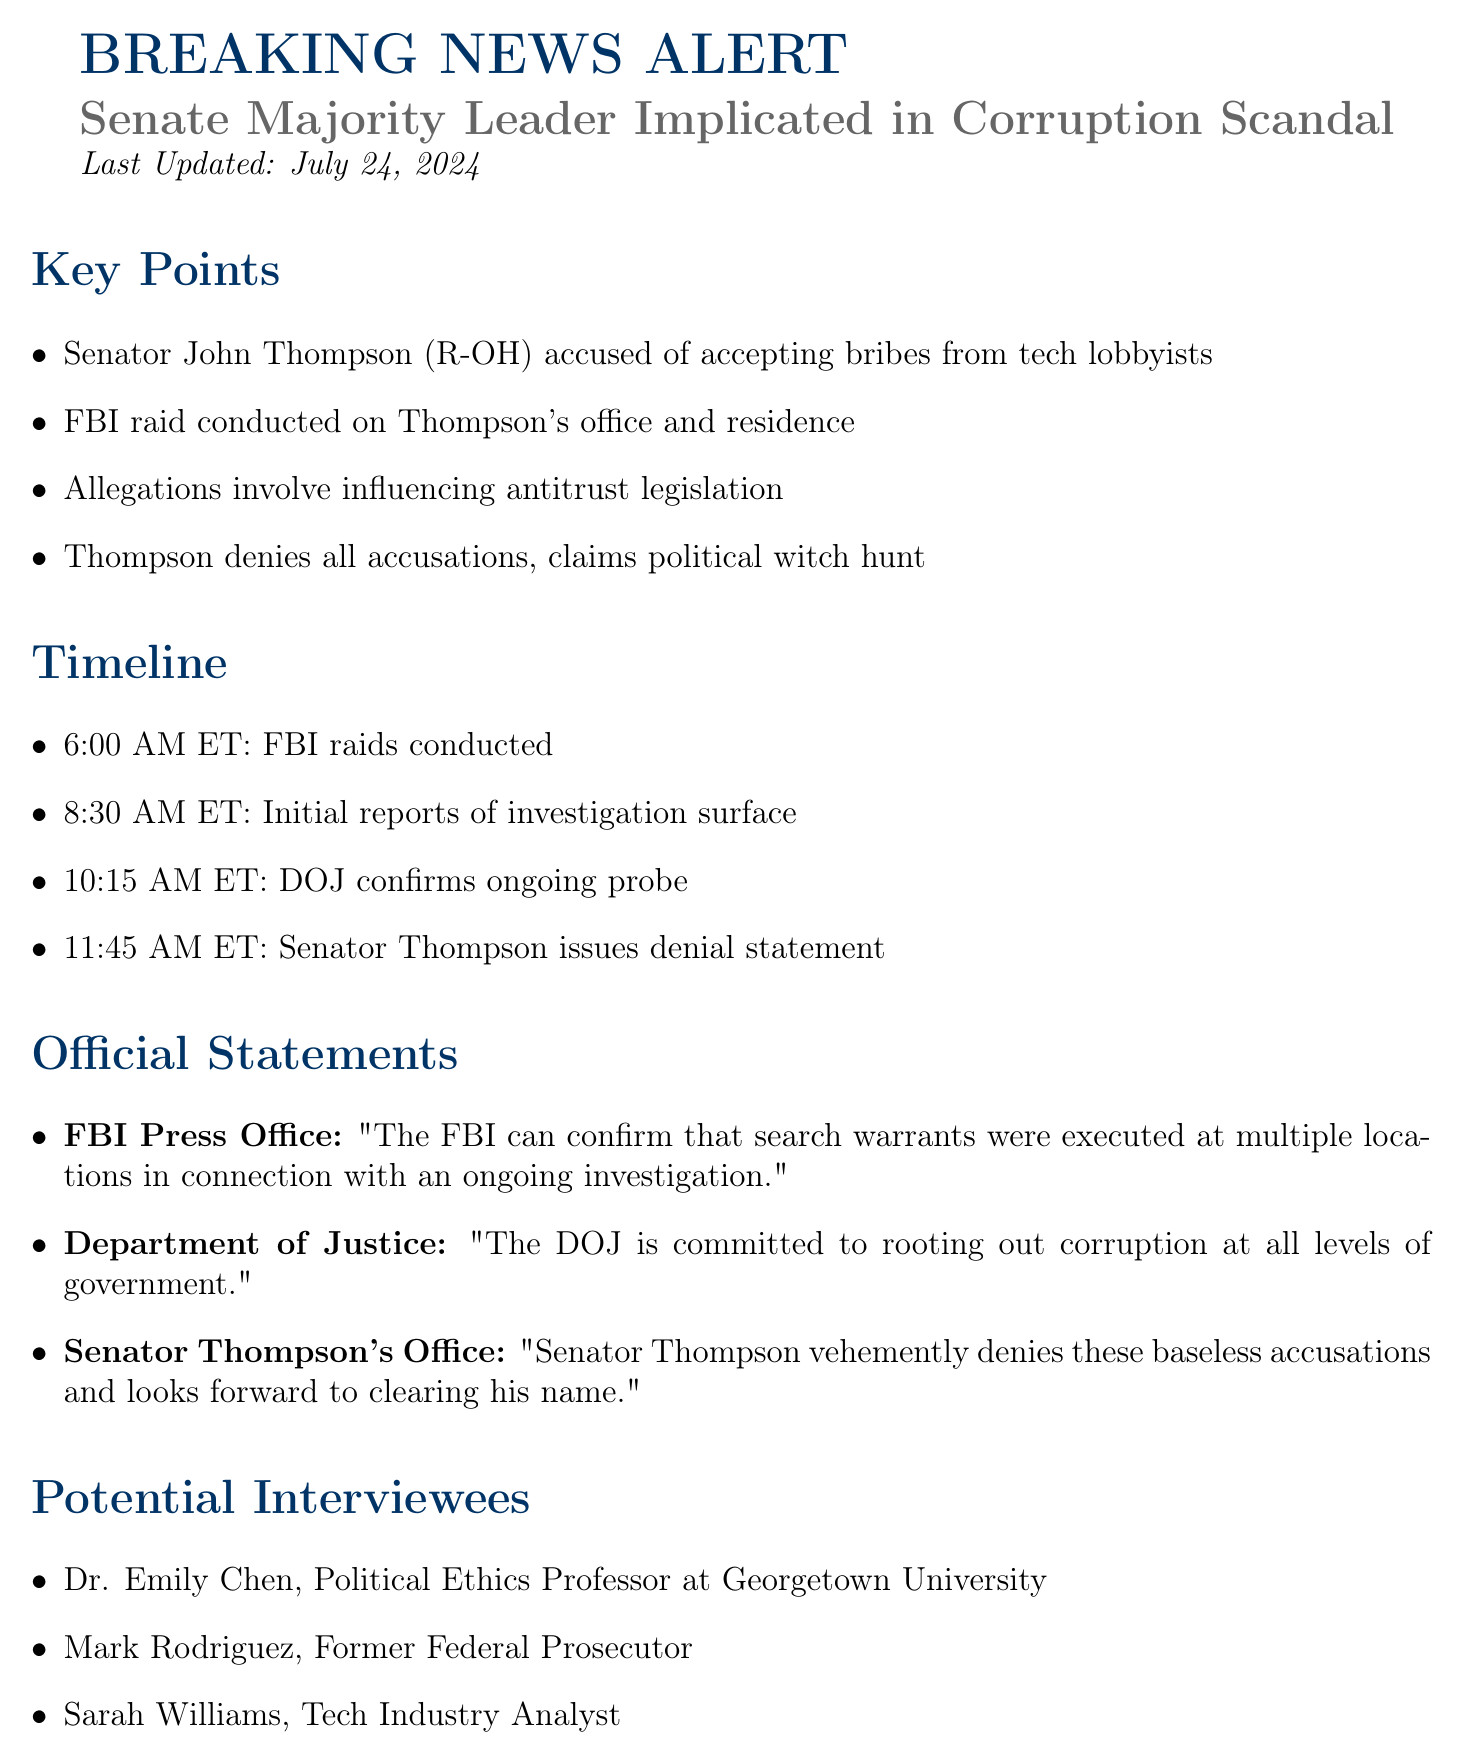What is the name of the Senator implicated? The document states that Senator John Thompson is the one implicated in the corruption scandal.
Answer: John Thompson What time did the FBI raids begin? The document provides a timeline indicating that the FBI raids were conducted at 6:00 AM ET.
Answer: 6:00 AM ET Which agency confirmed the search warrants were executed? According to the document, the FBI Press Office confirmed the execution of search warrants.
Answer: FBI What was Senator Thompson's response to the allegations? The document notes that Senator Thompson denies all accusations and claims it is a political witch hunt.
Answer: Political witch hunt Who is the Political Ethics Professor mentioned for potential interviews? The document lists Dr. Emily Chen as a potential interviewee and a Political Ethics Professor at Georgetown University.
Answer: Dr. Emily Chen What is the update frequency for the story? The document specifies that updates will be provided hourly as the story develops.
Answer: Hourly updates What is one of the related stories? The document lists related stories, including the "Recent push for stricter tech industry regulations."
Answer: Stricter tech industry regulations What time did Senator Thompson issue his denial statement? The document indicates that Senator Thompson issued his denial statement at 11:45 AM ET.
Answer: 11:45 AM ET What is the contact email for the DOJ? The document provides the email contact for the Department of Justice as media@usdoj.gov.
Answer: media@usdoj.gov 